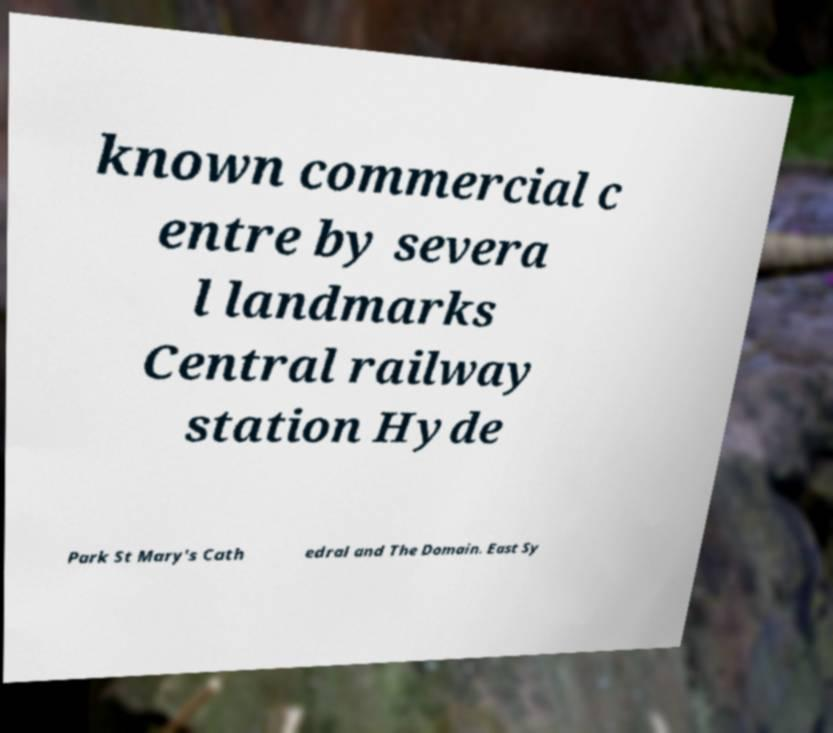Could you assist in decoding the text presented in this image and type it out clearly? known commercial c entre by severa l landmarks Central railway station Hyde Park St Mary's Cath edral and The Domain. East Sy 